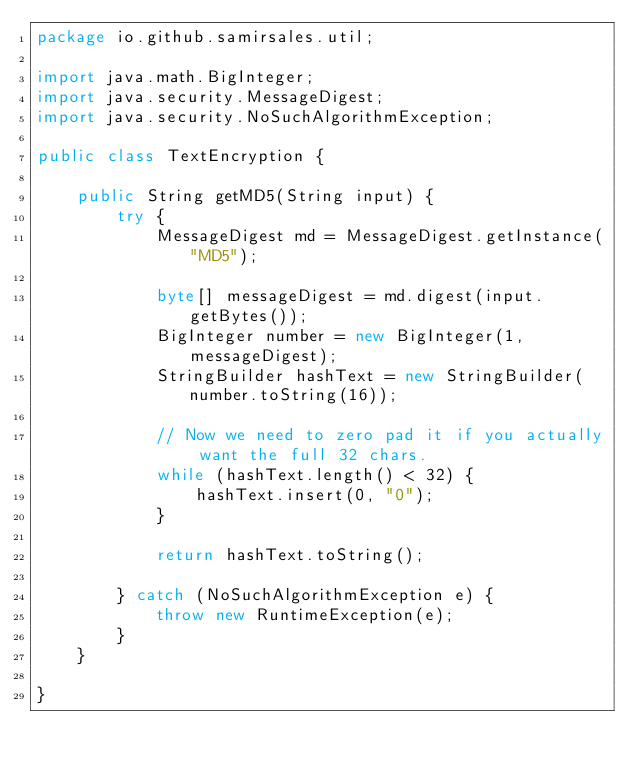<code> <loc_0><loc_0><loc_500><loc_500><_Java_>package io.github.samirsales.util;

import java.math.BigInteger;
import java.security.MessageDigest;
import java.security.NoSuchAlgorithmException;

public class TextEncryption {

    public String getMD5(String input) {
        try {
            MessageDigest md = MessageDigest.getInstance("MD5");

            byte[] messageDigest = md.digest(input.getBytes());
            BigInteger number = new BigInteger(1, messageDigest);
            StringBuilder hashText = new StringBuilder(number.toString(16));

            // Now we need to zero pad it if you actually want the full 32 chars.
            while (hashText.length() < 32) {
                hashText.insert(0, "0");
            }

            return hashText.toString();

        } catch (NoSuchAlgorithmException e) {
            throw new RuntimeException(e);
        }
    }

}
</code> 